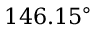Convert formula to latex. <formula><loc_0><loc_0><loc_500><loc_500>1 4 6 . 1 5 ^ { \circ }</formula> 